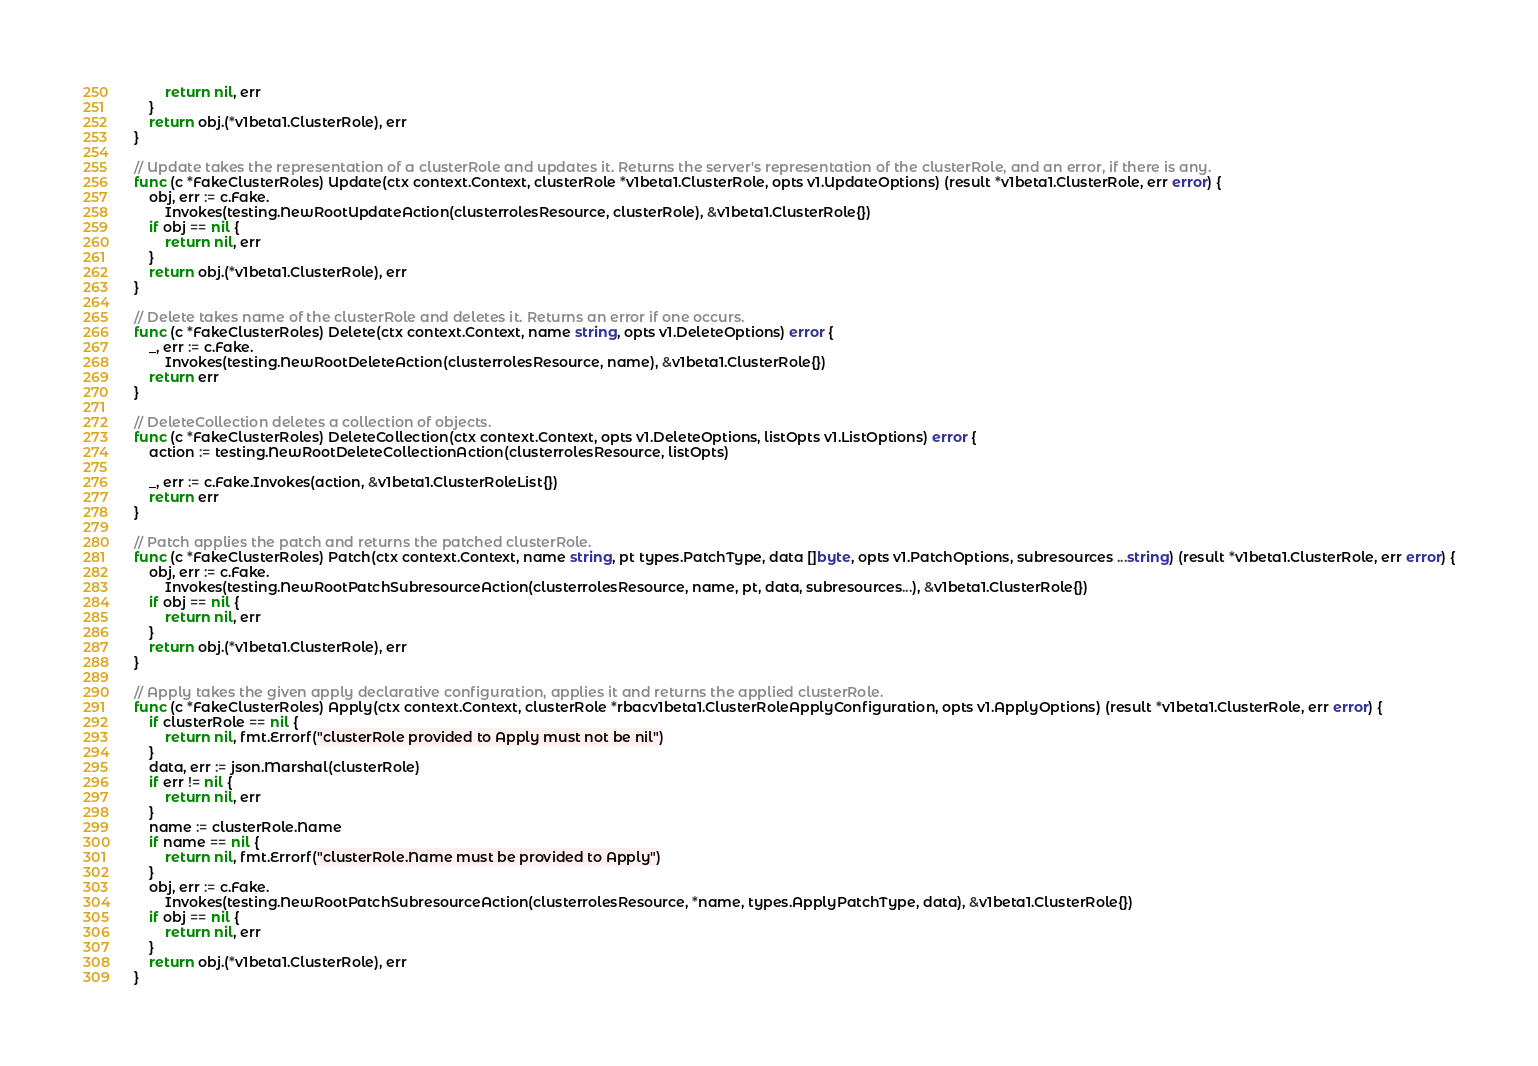Convert code to text. <code><loc_0><loc_0><loc_500><loc_500><_Go_>		return nil, err
	}
	return obj.(*v1beta1.ClusterRole), err
}

// Update takes the representation of a clusterRole and updates it. Returns the server's representation of the clusterRole, and an error, if there is any.
func (c *FakeClusterRoles) Update(ctx context.Context, clusterRole *v1beta1.ClusterRole, opts v1.UpdateOptions) (result *v1beta1.ClusterRole, err error) {
	obj, err := c.Fake.
		Invokes(testing.NewRootUpdateAction(clusterrolesResource, clusterRole), &v1beta1.ClusterRole{})
	if obj == nil {
		return nil, err
	}
	return obj.(*v1beta1.ClusterRole), err
}

// Delete takes name of the clusterRole and deletes it. Returns an error if one occurs.
func (c *FakeClusterRoles) Delete(ctx context.Context, name string, opts v1.DeleteOptions) error {
	_, err := c.Fake.
		Invokes(testing.NewRootDeleteAction(clusterrolesResource, name), &v1beta1.ClusterRole{})
	return err
}

// DeleteCollection deletes a collection of objects.
func (c *FakeClusterRoles) DeleteCollection(ctx context.Context, opts v1.DeleteOptions, listOpts v1.ListOptions) error {
	action := testing.NewRootDeleteCollectionAction(clusterrolesResource, listOpts)

	_, err := c.Fake.Invokes(action, &v1beta1.ClusterRoleList{})
	return err
}

// Patch applies the patch and returns the patched clusterRole.
func (c *FakeClusterRoles) Patch(ctx context.Context, name string, pt types.PatchType, data []byte, opts v1.PatchOptions, subresources ...string) (result *v1beta1.ClusterRole, err error) {
	obj, err := c.Fake.
		Invokes(testing.NewRootPatchSubresourceAction(clusterrolesResource, name, pt, data, subresources...), &v1beta1.ClusterRole{})
	if obj == nil {
		return nil, err
	}
	return obj.(*v1beta1.ClusterRole), err
}

// Apply takes the given apply declarative configuration, applies it and returns the applied clusterRole.
func (c *FakeClusterRoles) Apply(ctx context.Context, clusterRole *rbacv1beta1.ClusterRoleApplyConfiguration, opts v1.ApplyOptions) (result *v1beta1.ClusterRole, err error) {
	if clusterRole == nil {
		return nil, fmt.Errorf("clusterRole provided to Apply must not be nil")
	}
	data, err := json.Marshal(clusterRole)
	if err != nil {
		return nil, err
	}
	name := clusterRole.Name
	if name == nil {
		return nil, fmt.Errorf("clusterRole.Name must be provided to Apply")
	}
	obj, err := c.Fake.
		Invokes(testing.NewRootPatchSubresourceAction(clusterrolesResource, *name, types.ApplyPatchType, data), &v1beta1.ClusterRole{})
	if obj == nil {
		return nil, err
	}
	return obj.(*v1beta1.ClusterRole), err
}
</code> 